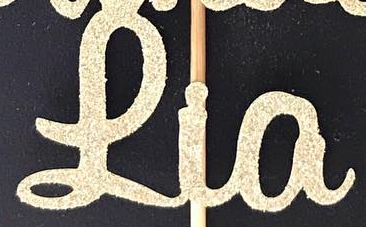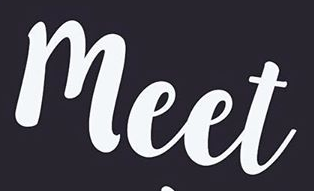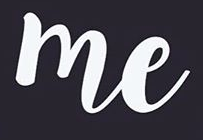What text appears in these images from left to right, separated by a semicolon? Lia; meet; me 